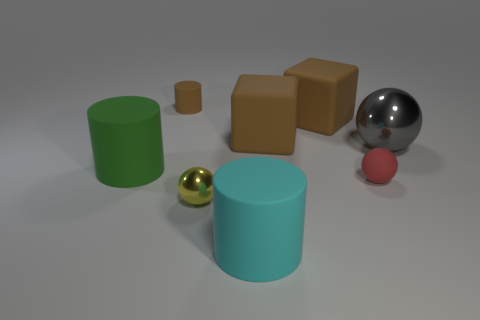Subtract all brown matte cylinders. How many cylinders are left? 2 Add 1 cubes. How many objects exist? 9 Subtract all cubes. How many objects are left? 6 Subtract all red matte balls. Subtract all brown cubes. How many objects are left? 5 Add 2 yellow objects. How many yellow objects are left? 3 Add 2 big cubes. How many big cubes exist? 4 Subtract 1 cyan cylinders. How many objects are left? 7 